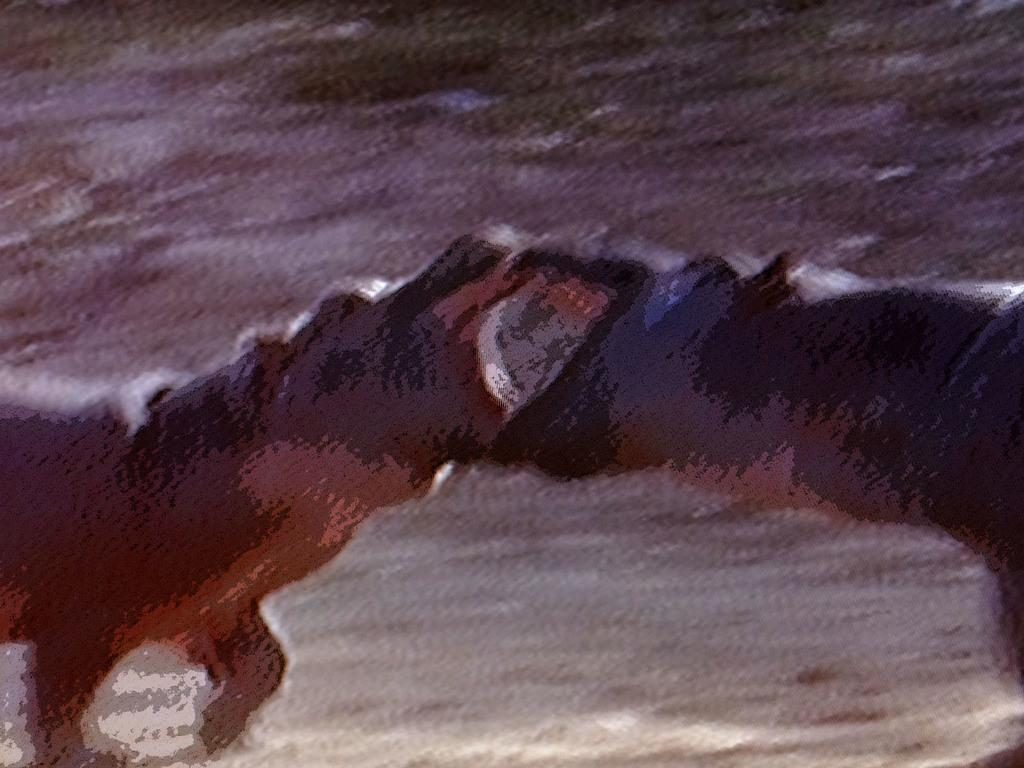How many hippopotamuses are present in the image? There are 2 hippopotamuses in the image. What are the hippopotamuses doing in the image? The hippopotamuses are fighting with their heads. What type of boundary can be seen between the two hippopotamuses in the image? There is no boundary visible between the two hippopotamuses in the image; they are engaged in a fight. How many boys are present in the image? There are no boys present in the image; it features two hippopotamuses. 